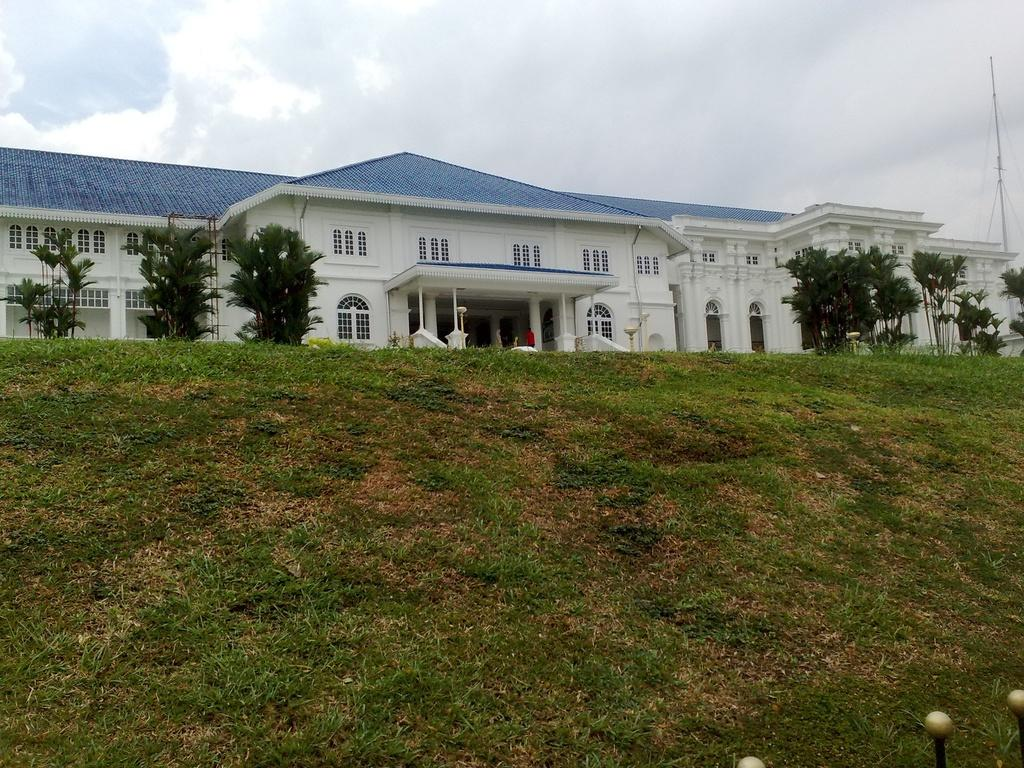What type of vegetation is present in the image? There is grass and trees in the image. What type of structure can be seen in the image? There is a building in the image. What can be seen through the windows in the image? The windows in the image provide a view of the grass, trees, and sky. Who or what is present in the image? There is a person in the image. What else can be seen in the image besides the person and the building? There are objects in the image. What is visible in the background of the image? The sky is visible in the background of the image, with clouds present. What type of police officer is related to the person in the image? There is no police officer or any reference to a police officer in the image. What type of uncle is present in the image? There is no uncle or any reference to an uncle in the image. 